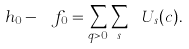Convert formula to latex. <formula><loc_0><loc_0><loc_500><loc_500>\ h _ { 0 } - \ f _ { 0 } = \sum _ { q > 0 } \sum _ { s } \ U _ { s } ( c ) .</formula> 